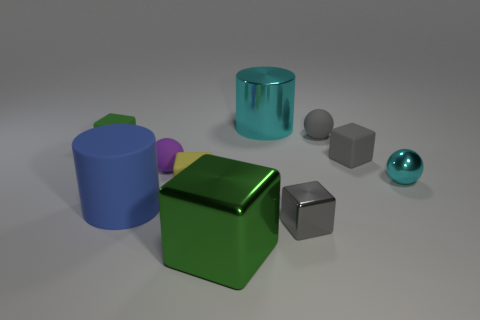What number of other things are the same color as the rubber cylinder?
Your answer should be very brief. 0. There is a big thing that is behind the blue rubber thing; is it the same shape as the green metal thing?
Give a very brief answer. No. There is a large blue rubber object that is behind the big cube; is there a tiny gray block on the left side of it?
Provide a short and direct response. No. What number of green blocks are there?
Give a very brief answer. 2. There is a small matte cube that is both on the left side of the green shiny block and on the right side of the matte cylinder; what is its color?
Your answer should be very brief. Yellow. There is a metal object that is the same shape as the large blue rubber object; what size is it?
Offer a very short reply. Large. How many brown shiny cylinders are the same size as the cyan shiny ball?
Provide a short and direct response. 0. What is the material of the large cyan cylinder?
Give a very brief answer. Metal. There is a large cyan metallic cylinder; are there any rubber things behind it?
Your answer should be very brief. No. There is a green object that is made of the same material as the big cyan thing; what is its size?
Ensure brevity in your answer.  Large. 